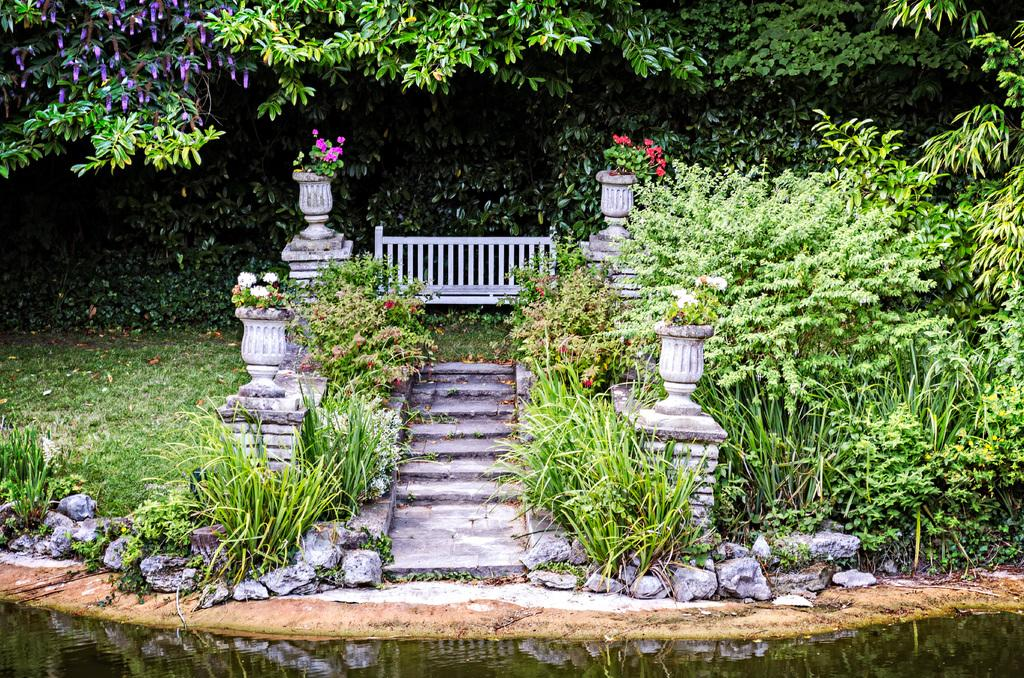What type of structure is visible in the image? There are stairs in the image. What is used to enclose or separate areas in the image? There is fencing in the image. What type of terrain is present in the image? There is grassy land in the image. What type of vegetation can be seen in the image? There are plants and trees in the image. What is the body of water in the image? Water is present at the bottom of the image. What type of fruit is being held by the person in the image? There is no person present in the image, and therefore no fruit can be observed. How does the wrist of the person in the image appear? There is no person present in the image, and therefore no wrist can be observed. 